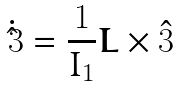Convert formula to latex. <formula><loc_0><loc_0><loc_500><loc_500>\dot { \hat { 3 } } = \frac { 1 } { I _ { 1 } } \boldsymbol L \times \hat { 3 }</formula> 